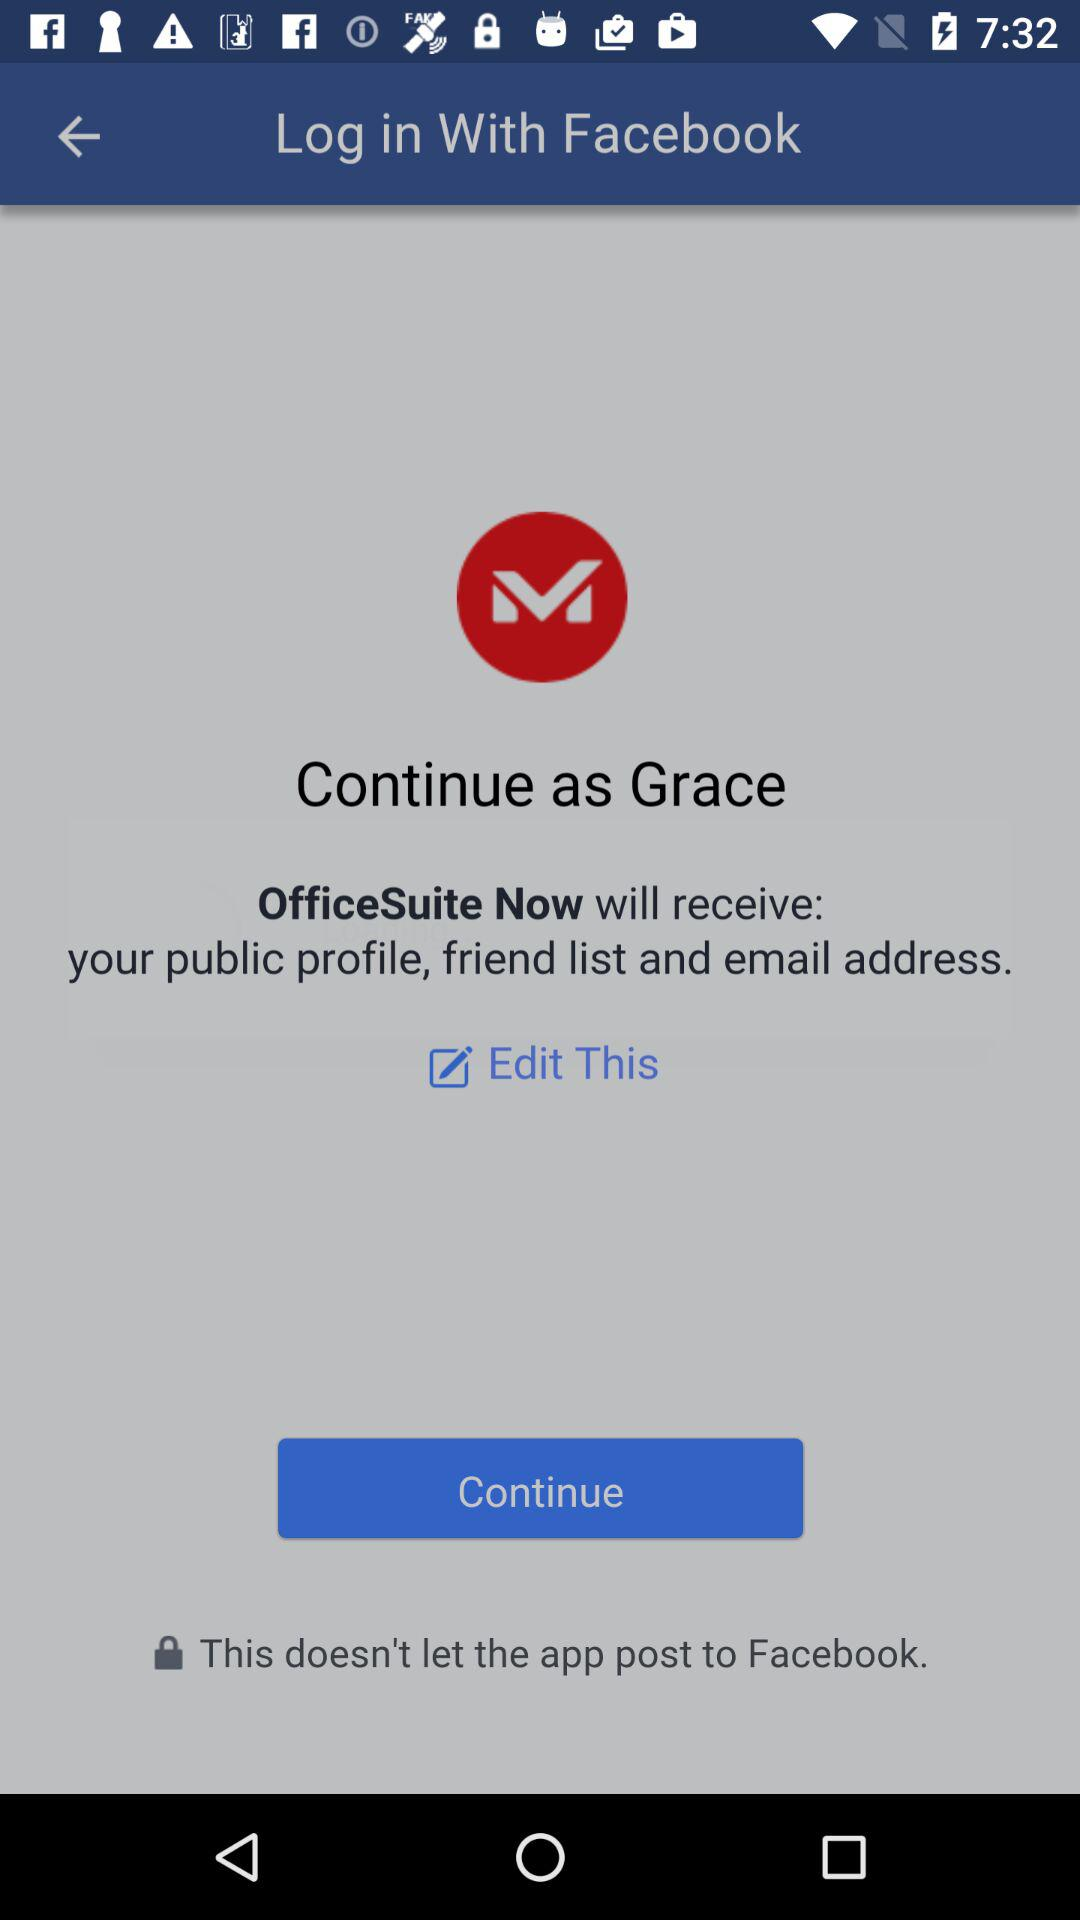What is the login name? The login name is Grace. 